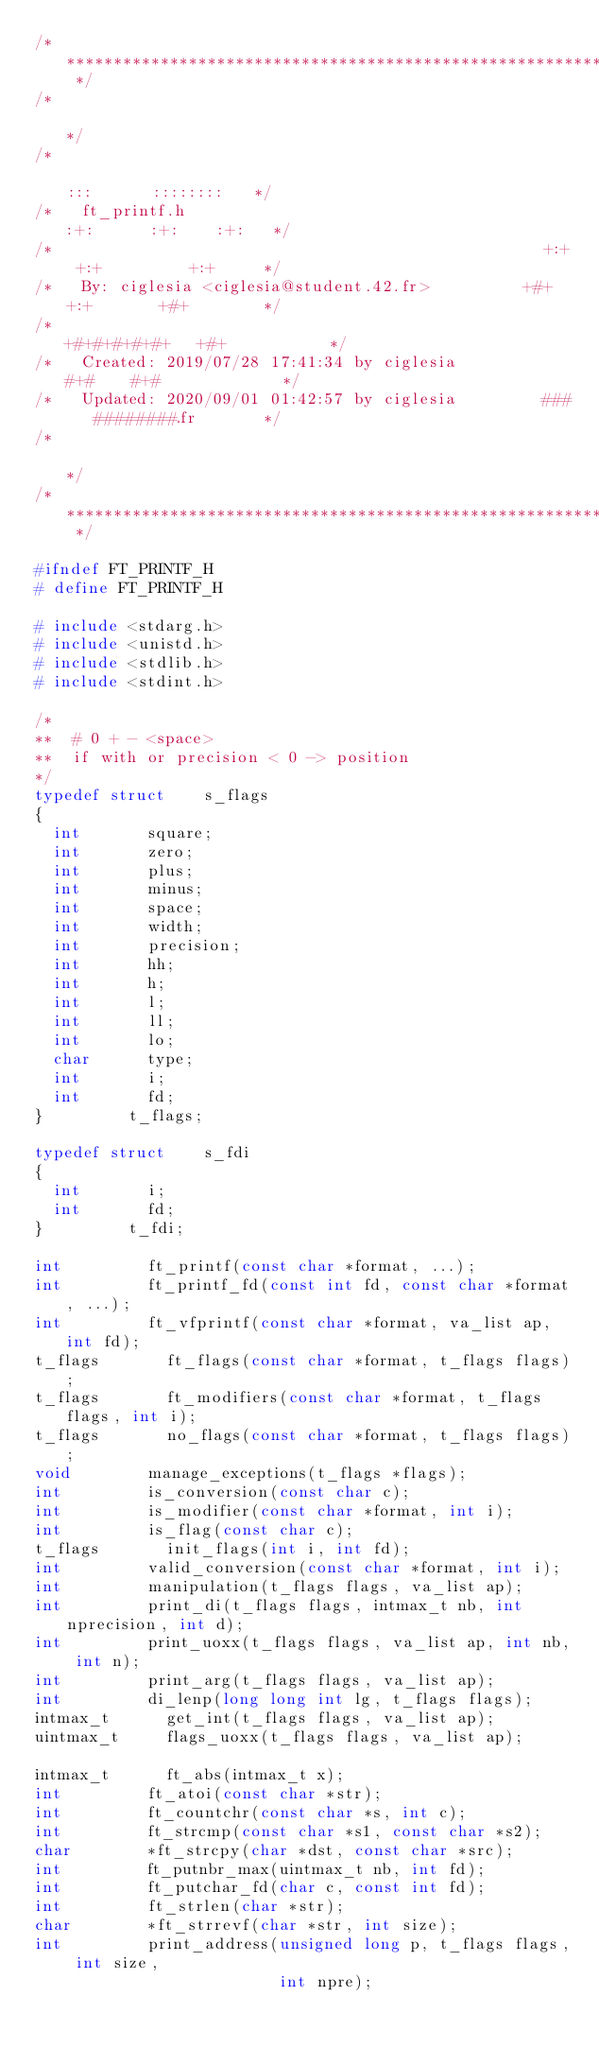<code> <loc_0><loc_0><loc_500><loc_500><_C_>/* ************************************************************************** */
/*                                                                            */
/*                                                        :::      ::::::::   */
/*   ft_printf.h                                        :+:      :+:    :+:   */
/*                                                    +:+ +:+         +:+     */
/*   By: ciglesia <ciglesia@student.42.fr>          +#+  +:+       +#+        */
/*                                                +#+#+#+#+#+   +#+           */
/*   Created: 2019/07/28 17:41:34 by ciglesia          #+#    #+#             */
/*   Updated: 2020/09/01 01:42:57 by ciglesia         ###   ########.fr       */
/*                                                                            */
/* ************************************************************************** */

#ifndef FT_PRINTF_H
# define FT_PRINTF_H

# include <stdarg.h>
# include <unistd.h>
# include <stdlib.h>
# include <stdint.h>

/*
**  # 0 + - <space>
**  if with or precision < 0 -> position
*/
typedef struct		s_flags
{
	int				square;
	int				zero;
	int				plus;
	int				minus;
	int				space;
	int				width;
	int				precision;
	int				hh;
	int				h;
	int				l;
	int				ll;
	int				lo;
	char			type;
	int				i;
	int				fd;
}					t_flags;

typedef struct		s_fdi
{
	int				i;
	int				fd;
}					t_fdi;

int					ft_printf(const char *format, ...);
int					ft_printf_fd(const int fd, const char *format, ...);
int					ft_vfprintf(const char *format, va_list ap, int fd);
t_flags				ft_flags(const char *format, t_flags flags);
t_flags				ft_modifiers(const char *format, t_flags flags, int i);
t_flags				no_flags(const char *format, t_flags flags);
void				manage_exceptions(t_flags *flags);
int					is_conversion(const char c);
int					is_modifier(const char *format, int i);
int					is_flag(const char c);
t_flags				init_flags(int i, int fd);
int					valid_conversion(const char *format, int i);
int					manipulation(t_flags flags, va_list ap);
int					print_di(t_flags flags, intmax_t nb, int nprecision, int d);
int					print_uoxx(t_flags flags, va_list ap, int nb, int n);
int					print_arg(t_flags flags, va_list ap);
int					di_lenp(long long int lg, t_flags flags);
intmax_t			get_int(t_flags flags, va_list ap);
uintmax_t			flags_uoxx(t_flags flags, va_list ap);

intmax_t			ft_abs(intmax_t x);
int					ft_atoi(const char *str);
int					ft_countchr(const char *s, int c);
int					ft_strcmp(const char *s1, const char *s2);
char				*ft_strcpy(char *dst, const char *src);
int					ft_putnbr_max(uintmax_t nb, int fd);
int					ft_putchar_fd(char c, const int fd);
int					ft_strlen(char *str);
char				*ft_strrevf(char *str, int size);
int					print_address(unsigned long p, t_flags flags, int size,
													int npre);</code> 